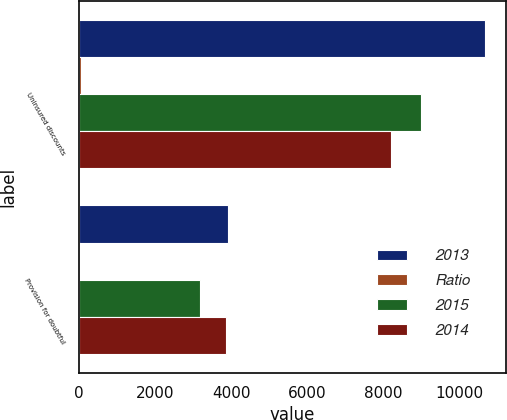Convert chart. <chart><loc_0><loc_0><loc_500><loc_500><stacked_bar_chart><ecel><fcel>Uninsured discounts<fcel>Provision for doubtful<nl><fcel>2013<fcel>10692<fcel>3913<nl><fcel>Ratio<fcel>59<fcel>21<nl><fcel>2015<fcel>8999<fcel>3169<nl><fcel>2014<fcel>8210<fcel>3858<nl></chart> 